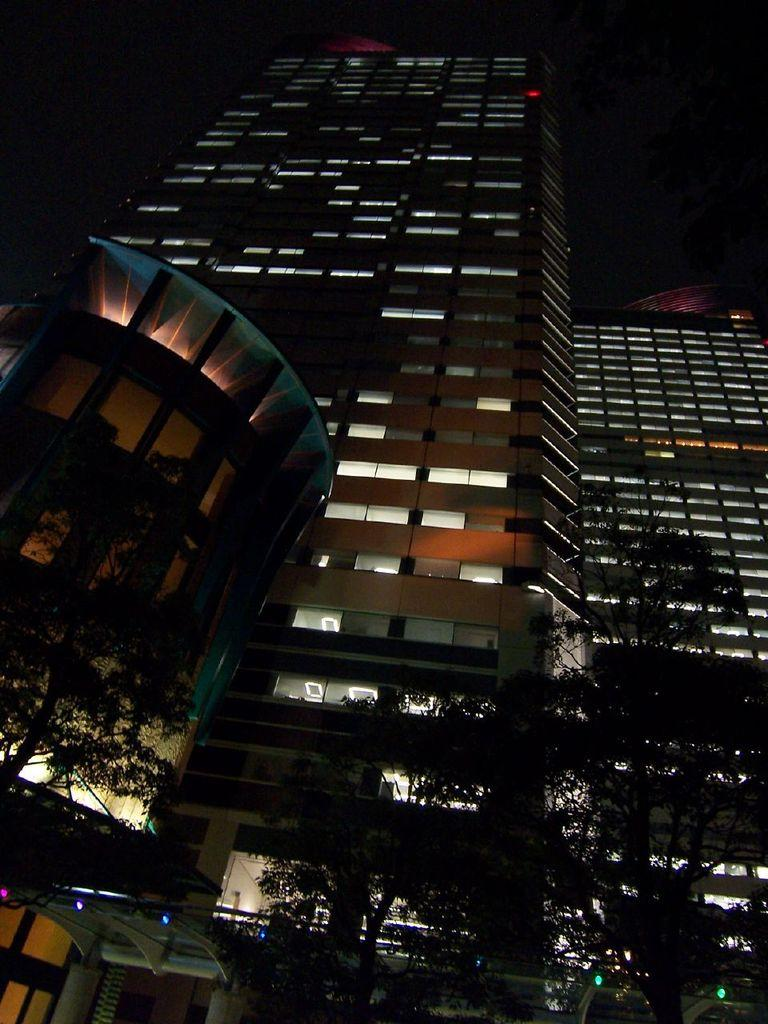What structures are illuminated in the image? There are buildings with lights in the image. What type of vegetation is present at the bottom of the image? There are trees at the bottom of the image. How would you describe the overall lighting in the image? The background of the image is dark. Can you see a pear hanging from one of the trees in the image? There is no pear visible in the image; only trees are present at the bottom. 